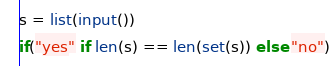Convert code to text. <code><loc_0><loc_0><loc_500><loc_500><_Python_>s = list(input())
if("yes" if len(s) == len(set(s)) else "no")</code> 